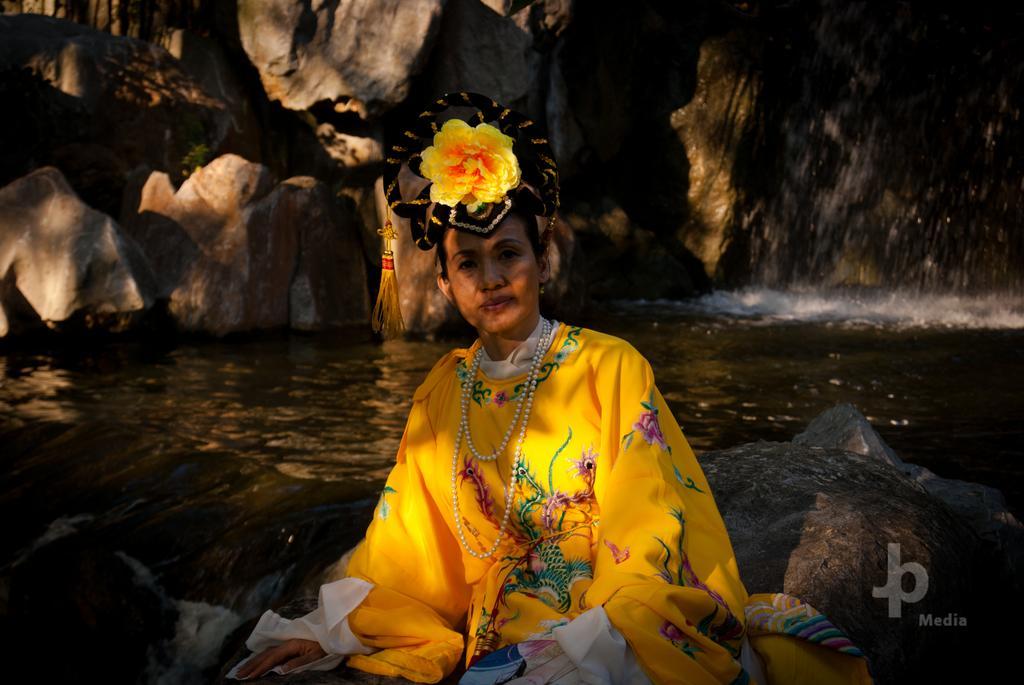Describe this image in one or two sentences. There is a woman sitting on a rock. Here we can see water. In the background we can see a mountain. 